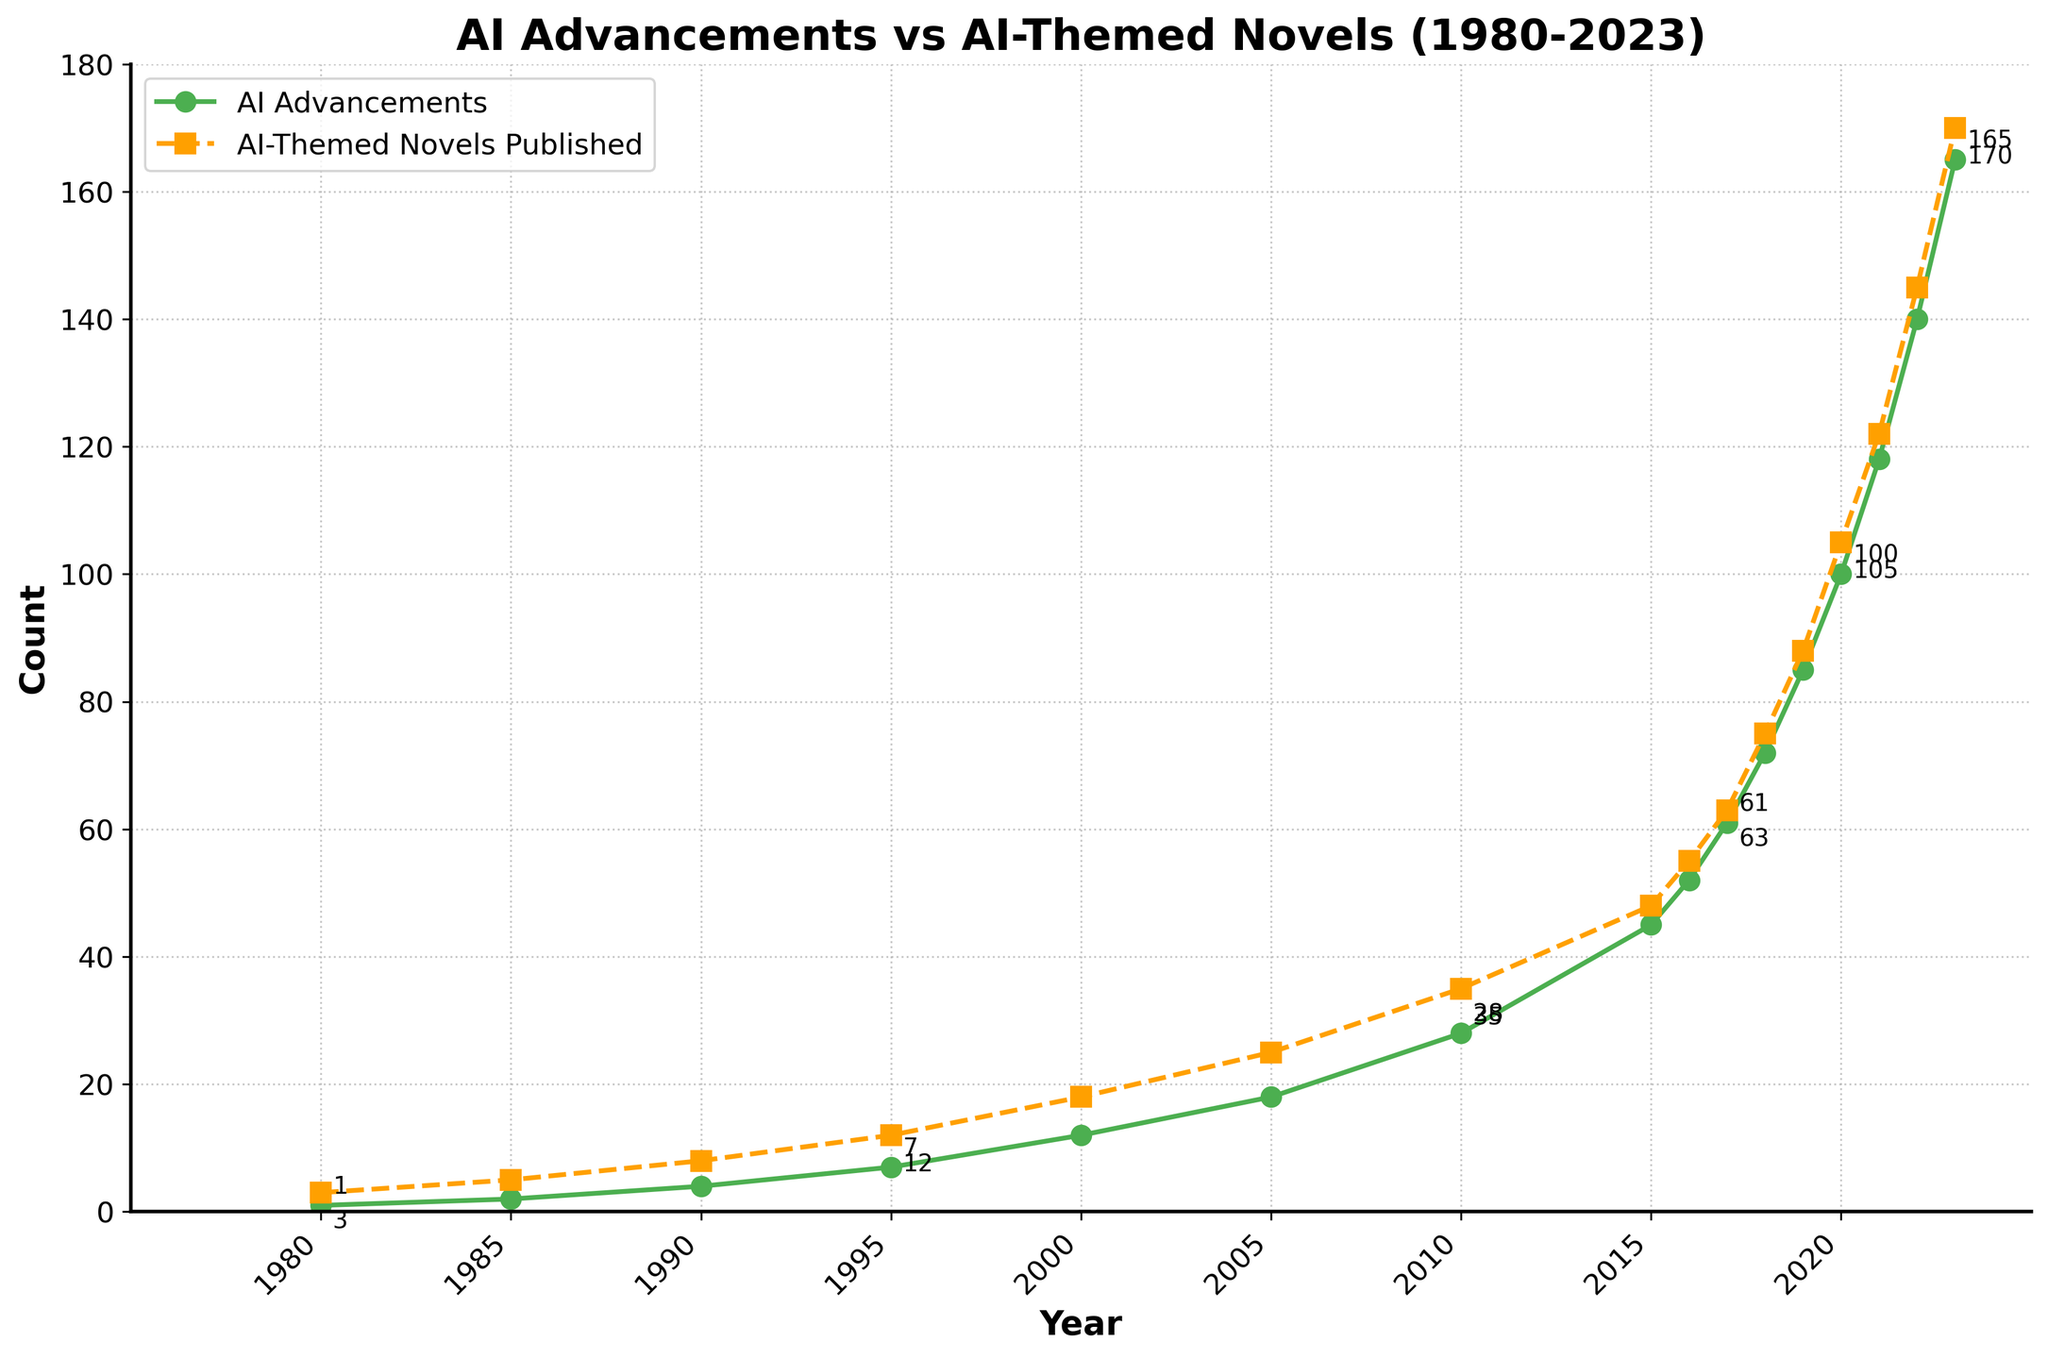what year saw the biggest increase in AI advancements from the previous year? From the figure, we see the data points for AI advancements rising annually. The biggest increase can be observed between 2015 (45) and 2016 (52). The difference is 52 - 45 = 7. The next highest increase occurred from 2019 (85) to 2020 (100) with a difference of 15. Hence, 2019 to 2020 saw the biggest increase.
Answer: 2020 Which year had an equal number of AI advancements and AI-themed novels published, according to the figure? The chart shows both lines closely but distinctly. We see that in most years, the number of novels published is either lower or higher than AI advancements. However, there is no year where the counts for both AI advancements and AI-themed novels are equal.
Answer: None How many AI-themed novels were published in the year 2000, and how did this compare to AI advancements in the same year? The figure indicates that in the year 2000, AI-themed novels published were 18, while AI advancements were 12. The number of novels published was higher than the AI advancements by 18-12 = 6.
Answer: 18, higher by 6 What trend appears visible when comparing the trajectory of AI advancements to the publication of AI-themed novels from 1980 to 2023? Observing the figure, the trend shows both AI advancements and AI-themed novels published following an upward trajectory. From 1980 onward, both metrics steadily increase, with AI advancements slightly lagging behind the novels initially but rapidly catching up and aligning closely as the years progress.
Answer: Both increased, AI advancements catching up Which year had the highest number of AI-themed novels published, and how many were there? From the figure, the peak number of AI-themed novels published is in the year 2023, with a total of 170 novels. This is at the top right end of the AI-themed novels published line.
Answer: 2023, 170 By what margin did AI advancements and AI-themed novels published differ in 2022? Observing the figure for 2022, AI advancements were recorded at 140, whereas AI-themed novels published were at 145. The margin of difference between these two numbers is 145 - 140 = 5.
Answer: 5 Calculate the average number of AI advancements from 2015 to 2020. From the figure, the data points for AI advancements over the years 2015 to 2020 are 45 (2015), 52 (2016), 61 (2017), 72 (2018), 85 (2019), and 100 (2020). The average can be calculated by adding these values and dividing by the number of years: (45 + 52 + 61 + 72 + 85 + 100) / 6 = 68.
Answer: 68 